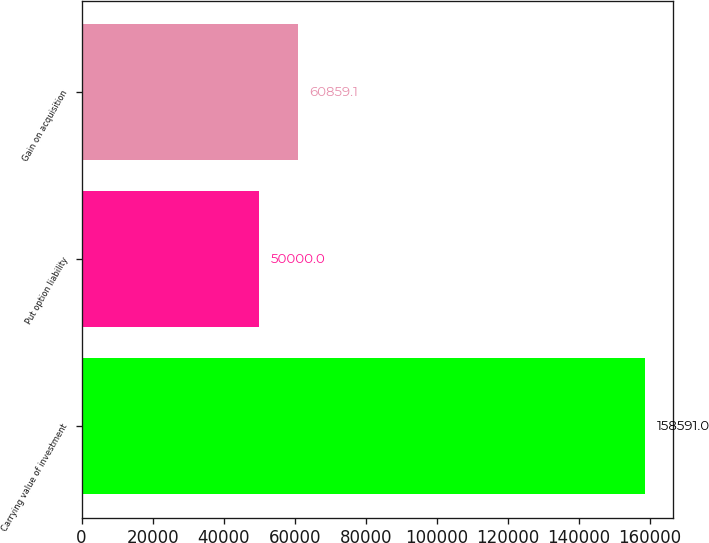Convert chart to OTSL. <chart><loc_0><loc_0><loc_500><loc_500><bar_chart><fcel>Carrying value of investment<fcel>Put option liability<fcel>Gain on acquisition<nl><fcel>158591<fcel>50000<fcel>60859.1<nl></chart> 